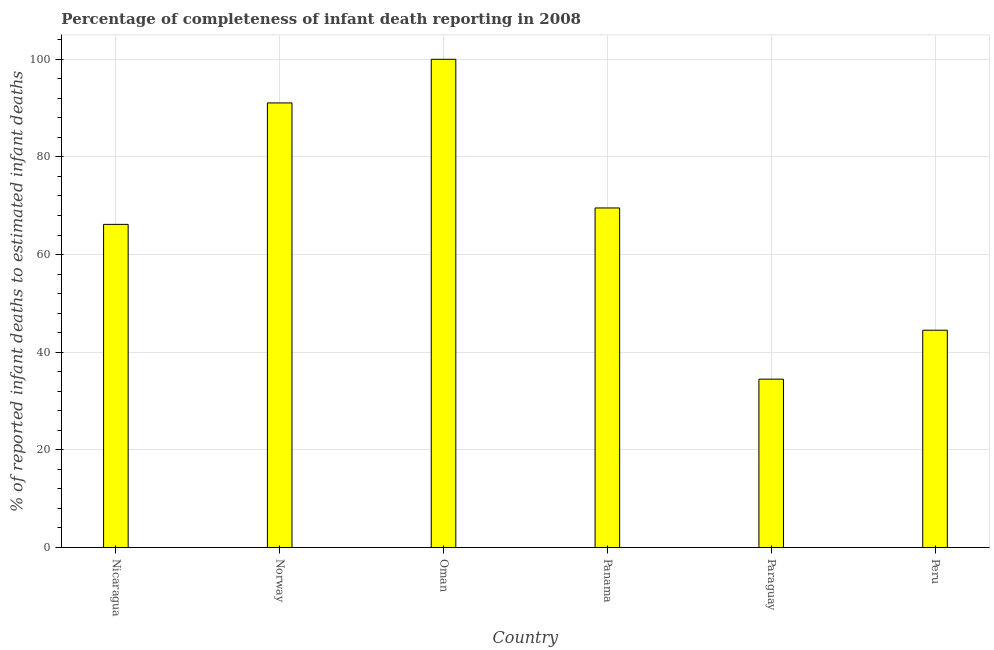Does the graph contain any zero values?
Provide a short and direct response. No. What is the title of the graph?
Provide a succinct answer. Percentage of completeness of infant death reporting in 2008. What is the label or title of the Y-axis?
Your answer should be very brief. % of reported infant deaths to estimated infant deaths. What is the completeness of infant death reporting in Panama?
Provide a short and direct response. 69.55. Across all countries, what is the maximum completeness of infant death reporting?
Offer a very short reply. 100. Across all countries, what is the minimum completeness of infant death reporting?
Give a very brief answer. 34.49. In which country was the completeness of infant death reporting maximum?
Ensure brevity in your answer.  Oman. In which country was the completeness of infant death reporting minimum?
Keep it short and to the point. Paraguay. What is the sum of the completeness of infant death reporting?
Your response must be concise. 405.79. What is the difference between the completeness of infant death reporting in Panama and Peru?
Provide a succinct answer. 25.04. What is the average completeness of infant death reporting per country?
Provide a succinct answer. 67.63. What is the median completeness of infant death reporting?
Make the answer very short. 67.87. What is the ratio of the completeness of infant death reporting in Oman to that in Paraguay?
Provide a short and direct response. 2.9. Is the completeness of infant death reporting in Norway less than that in Oman?
Offer a terse response. Yes. What is the difference between the highest and the second highest completeness of infant death reporting?
Your answer should be very brief. 8.94. What is the difference between the highest and the lowest completeness of infant death reporting?
Your answer should be compact. 65.51. How many bars are there?
Provide a short and direct response. 6. Are all the bars in the graph horizontal?
Provide a succinct answer. No. What is the % of reported infant deaths to estimated infant deaths of Nicaragua?
Your response must be concise. 66.19. What is the % of reported infant deaths to estimated infant deaths of Norway?
Your response must be concise. 91.06. What is the % of reported infant deaths to estimated infant deaths in Panama?
Make the answer very short. 69.55. What is the % of reported infant deaths to estimated infant deaths of Paraguay?
Provide a succinct answer. 34.49. What is the % of reported infant deaths to estimated infant deaths of Peru?
Provide a short and direct response. 44.51. What is the difference between the % of reported infant deaths to estimated infant deaths in Nicaragua and Norway?
Give a very brief answer. -24.87. What is the difference between the % of reported infant deaths to estimated infant deaths in Nicaragua and Oman?
Offer a terse response. -33.81. What is the difference between the % of reported infant deaths to estimated infant deaths in Nicaragua and Panama?
Offer a terse response. -3.36. What is the difference between the % of reported infant deaths to estimated infant deaths in Nicaragua and Paraguay?
Offer a terse response. 31.7. What is the difference between the % of reported infant deaths to estimated infant deaths in Nicaragua and Peru?
Provide a succinct answer. 21.68. What is the difference between the % of reported infant deaths to estimated infant deaths in Norway and Oman?
Your response must be concise. -8.94. What is the difference between the % of reported infant deaths to estimated infant deaths in Norway and Panama?
Your answer should be very brief. 21.51. What is the difference between the % of reported infant deaths to estimated infant deaths in Norway and Paraguay?
Offer a terse response. 56.57. What is the difference between the % of reported infant deaths to estimated infant deaths in Norway and Peru?
Offer a terse response. 46.55. What is the difference between the % of reported infant deaths to estimated infant deaths in Oman and Panama?
Keep it short and to the point. 30.45. What is the difference between the % of reported infant deaths to estimated infant deaths in Oman and Paraguay?
Provide a succinct answer. 65.51. What is the difference between the % of reported infant deaths to estimated infant deaths in Oman and Peru?
Your answer should be very brief. 55.49. What is the difference between the % of reported infant deaths to estimated infant deaths in Panama and Paraguay?
Offer a terse response. 35.06. What is the difference between the % of reported infant deaths to estimated infant deaths in Panama and Peru?
Provide a short and direct response. 25.04. What is the difference between the % of reported infant deaths to estimated infant deaths in Paraguay and Peru?
Keep it short and to the point. -10.02. What is the ratio of the % of reported infant deaths to estimated infant deaths in Nicaragua to that in Norway?
Your response must be concise. 0.73. What is the ratio of the % of reported infant deaths to estimated infant deaths in Nicaragua to that in Oman?
Give a very brief answer. 0.66. What is the ratio of the % of reported infant deaths to estimated infant deaths in Nicaragua to that in Paraguay?
Your response must be concise. 1.92. What is the ratio of the % of reported infant deaths to estimated infant deaths in Nicaragua to that in Peru?
Offer a very short reply. 1.49. What is the ratio of the % of reported infant deaths to estimated infant deaths in Norway to that in Oman?
Offer a terse response. 0.91. What is the ratio of the % of reported infant deaths to estimated infant deaths in Norway to that in Panama?
Give a very brief answer. 1.31. What is the ratio of the % of reported infant deaths to estimated infant deaths in Norway to that in Paraguay?
Your response must be concise. 2.64. What is the ratio of the % of reported infant deaths to estimated infant deaths in Norway to that in Peru?
Your answer should be very brief. 2.05. What is the ratio of the % of reported infant deaths to estimated infant deaths in Oman to that in Panama?
Make the answer very short. 1.44. What is the ratio of the % of reported infant deaths to estimated infant deaths in Oman to that in Peru?
Ensure brevity in your answer.  2.25. What is the ratio of the % of reported infant deaths to estimated infant deaths in Panama to that in Paraguay?
Provide a succinct answer. 2.02. What is the ratio of the % of reported infant deaths to estimated infant deaths in Panama to that in Peru?
Keep it short and to the point. 1.56. What is the ratio of the % of reported infant deaths to estimated infant deaths in Paraguay to that in Peru?
Your response must be concise. 0.78. 